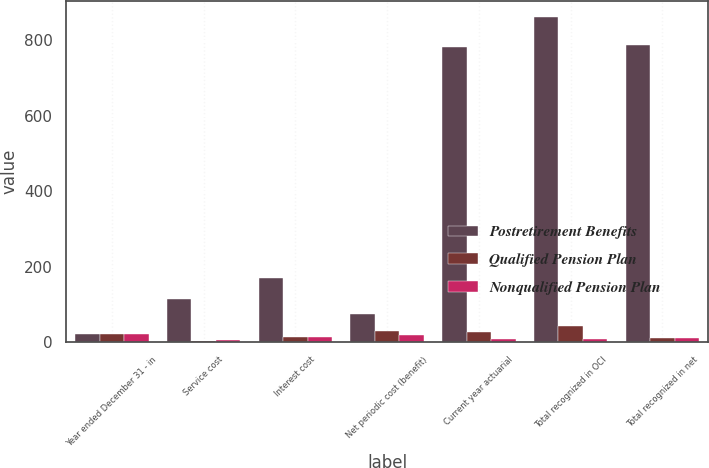Convert chart. <chart><loc_0><loc_0><loc_500><loc_500><stacked_bar_chart><ecel><fcel>Year ended December 31 - in<fcel>Service cost<fcel>Interest cost<fcel>Net periodic cost (benefit)<fcel>Current year actuarial<fcel>Total recognized in OCI<fcel>Total recognized in net<nl><fcel>Postretirement Benefits<fcel>22<fcel>113<fcel>170<fcel>74<fcel>784<fcel>863<fcel>789<nl><fcel>Qualified Pension Plan<fcel>22<fcel>3<fcel>12<fcel>30<fcel>26<fcel>41<fcel>11<nl><fcel>Nonqualified Pension Plan<fcel>22<fcel>6<fcel>14<fcel>18<fcel>9<fcel>7<fcel>11<nl></chart> 